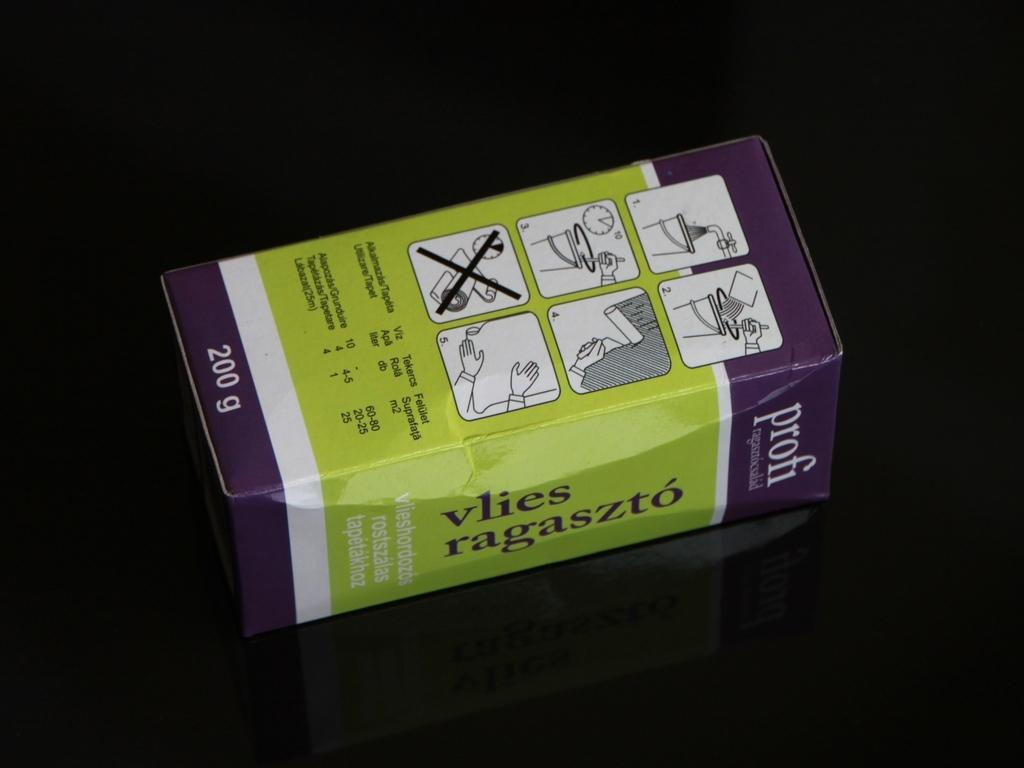<image>
Relay a brief, clear account of the picture shown. A 200 gram purple ad green box of profi vlies ragaszto sits on a black table. 